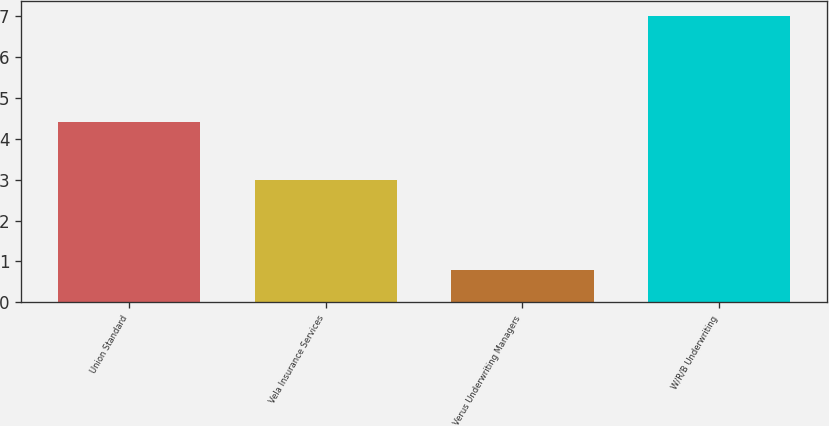Convert chart to OTSL. <chart><loc_0><loc_0><loc_500><loc_500><bar_chart><fcel>Union Standard<fcel>Vela Insurance Services<fcel>Verus Underwriting Managers<fcel>W/R/B Underwriting<nl><fcel>4.4<fcel>3<fcel>0.8<fcel>7<nl></chart> 